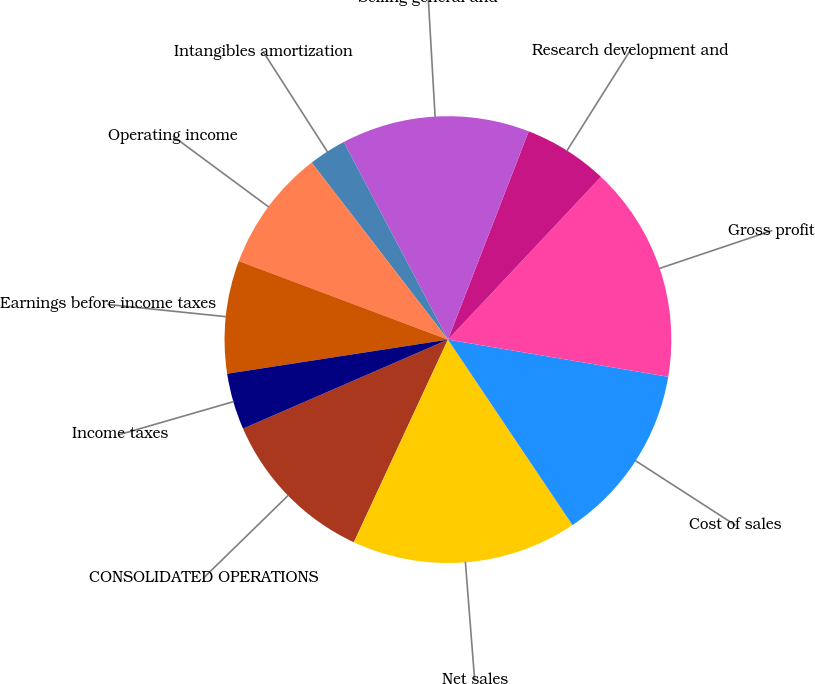Convert chart. <chart><loc_0><loc_0><loc_500><loc_500><pie_chart><fcel>CONSOLIDATED OPERATIONS<fcel>Net sales<fcel>Cost of sales<fcel>Gross profit<fcel>Research development and<fcel>Selling general and<fcel>Intangibles amortization<fcel>Operating income<fcel>Earnings before income taxes<fcel>Income taxes<nl><fcel>11.56%<fcel>16.33%<fcel>12.93%<fcel>15.65%<fcel>6.12%<fcel>13.61%<fcel>2.72%<fcel>8.84%<fcel>8.16%<fcel>4.08%<nl></chart> 